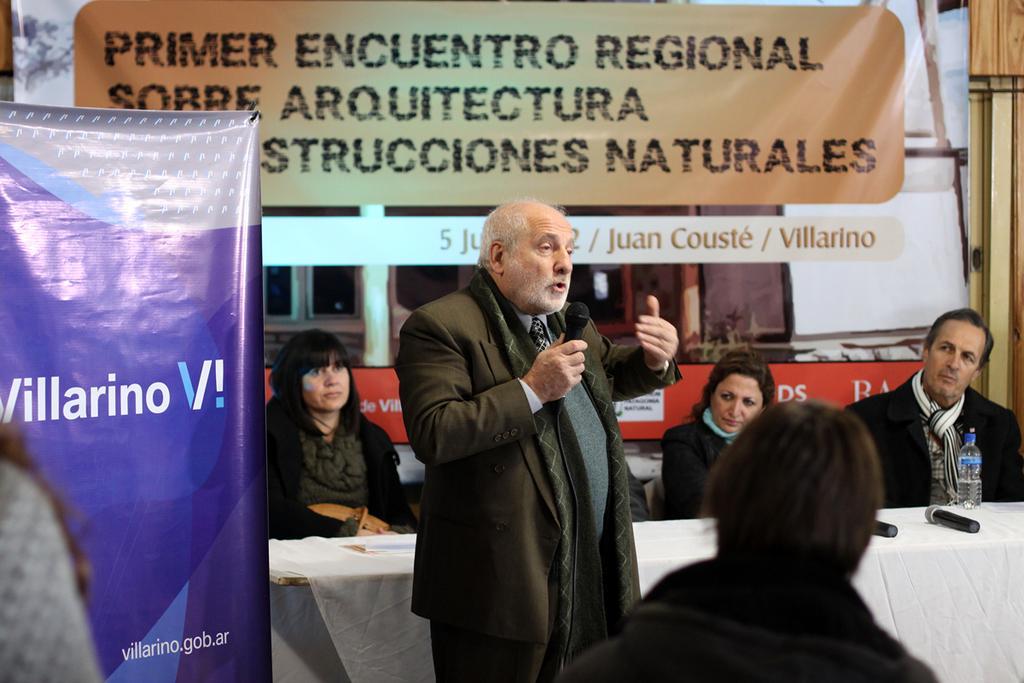Describe this image in one or two sentences. In this image we can see there is a person standing and holding a mic. And there are other people sitting on the chair. In front of them there is a table with a cloth, on the table there is a bottle. And at the side and the back there are banners with text. 